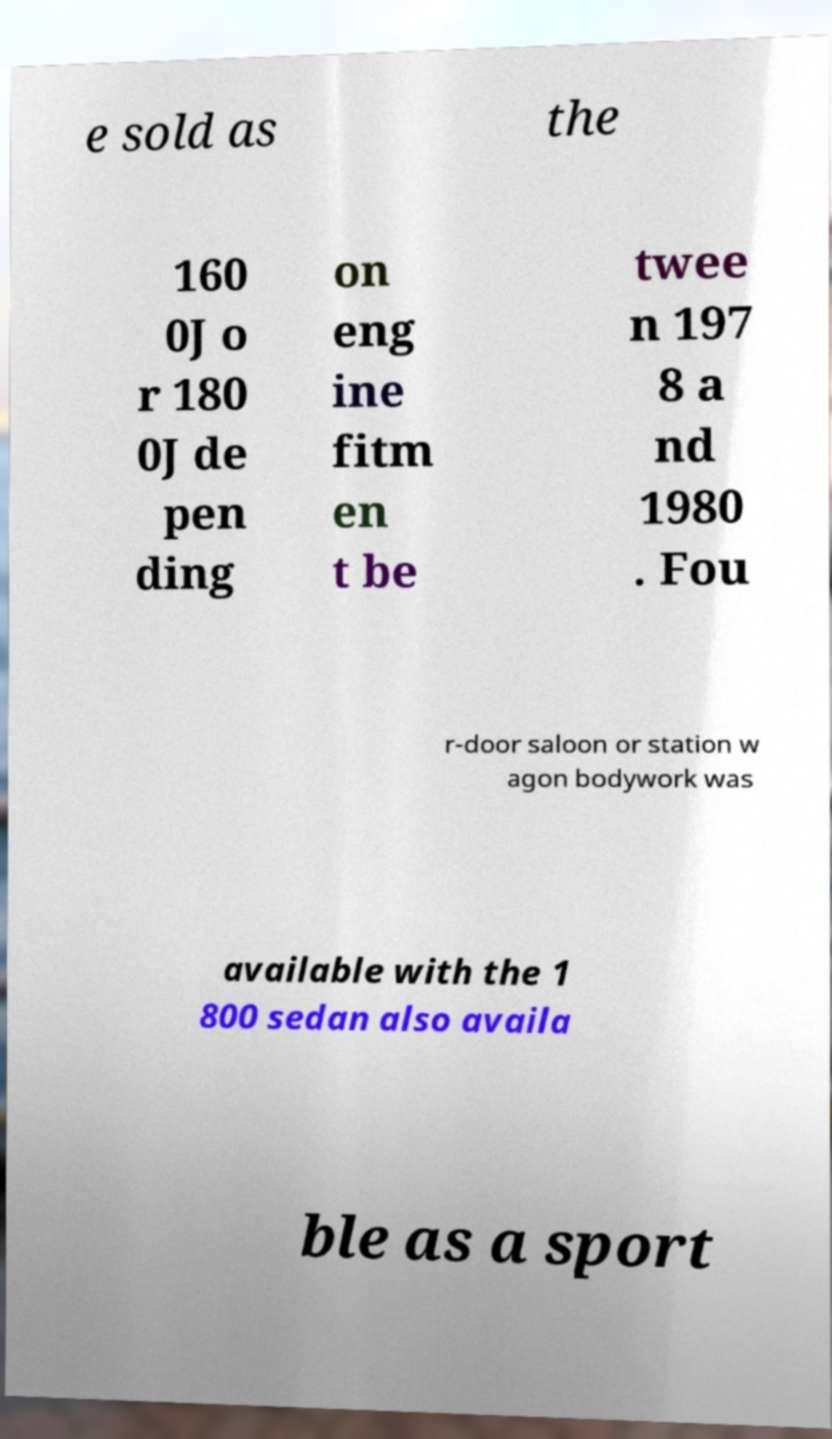Please identify and transcribe the text found in this image. e sold as the 160 0J o r 180 0J de pen ding on eng ine fitm en t be twee n 197 8 a nd 1980 . Fou r-door saloon or station w agon bodywork was available with the 1 800 sedan also availa ble as a sport 